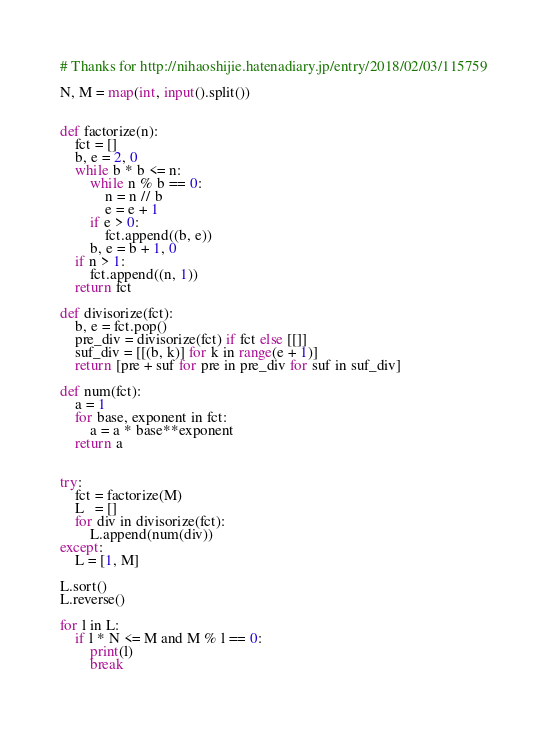<code> <loc_0><loc_0><loc_500><loc_500><_Python_># Thanks for http://nihaoshijie.hatenadiary.jp/entry/2018/02/03/115759

N, M = map(int, input().split())


def factorize(n):
    fct = []
    b, e = 2, 0
    while b * b <= n:
        while n % b == 0:
            n = n // b
            e = e + 1
        if e > 0:
            fct.append((b, e))
        b, e = b + 1, 0
    if n > 1:
        fct.append((n, 1))
    return fct

def divisorize(fct):
    b, e = fct.pop()
    pre_div = divisorize(fct) if fct else [[]]
    suf_div = [[(b, k)] for k in range(e + 1)]
    return [pre + suf for pre in pre_div for suf in suf_div]

def num(fct):
    a = 1
    for base, exponent in fct:
        a = a * base**exponent
    return a


try:
    fct = factorize(M)
    L   = []
    for div in divisorize(fct):
        L.append(num(div))
except:
    L = [1, M]

L.sort()
L.reverse()

for l in L:
    if l * N <= M and M % l == 0:
        print(l)
        break
</code> 